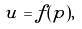Convert formula to latex. <formula><loc_0><loc_0><loc_500><loc_500>u = f ( p ) ,</formula> 